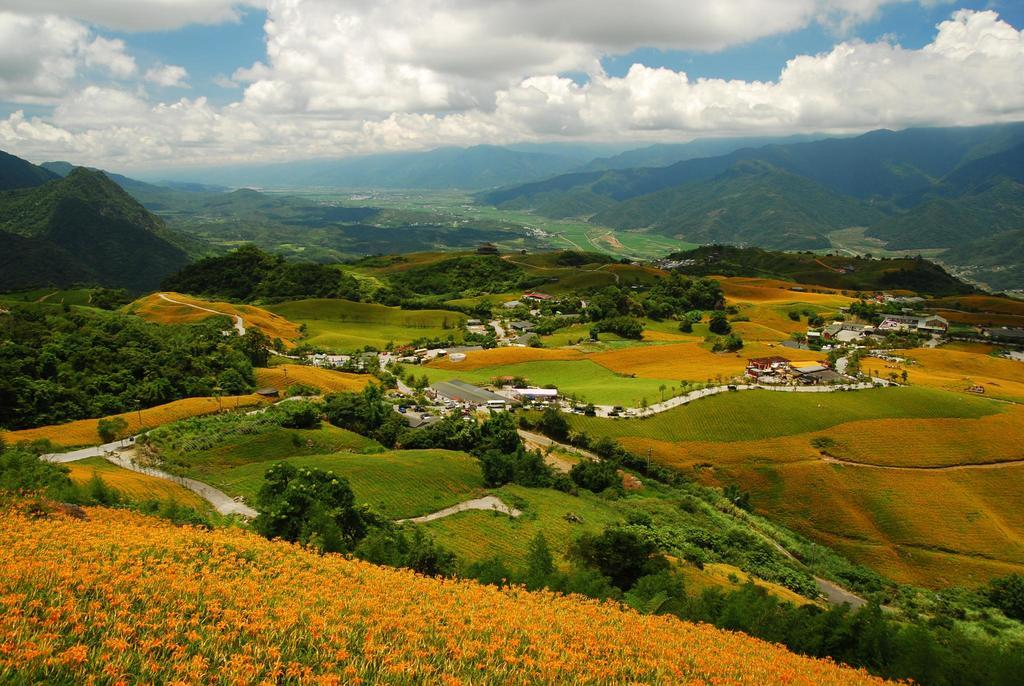What type of vegetation is in the foreground of the image? There are flower plants in the foreground of the image. What other types of vegetation can be seen in the image? There are trees in the image. What can be seen in the image that is not vegetation? There are green fields, houses, a road, and hills in the image. What is visible in the sky in the image? There are clouds in the sky in the image. What type of throat-soothing remedy is visible in the image? There is no throat-soothing remedy present in the image. Is there a tent visible in the image? No, there is no tent present in the image. 